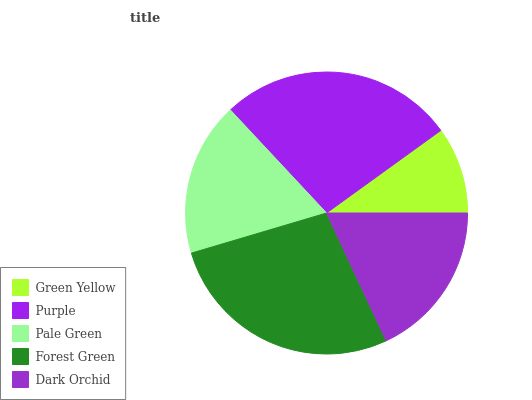Is Green Yellow the minimum?
Answer yes or no. Yes. Is Forest Green the maximum?
Answer yes or no. Yes. Is Purple the minimum?
Answer yes or no. No. Is Purple the maximum?
Answer yes or no. No. Is Purple greater than Green Yellow?
Answer yes or no. Yes. Is Green Yellow less than Purple?
Answer yes or no. Yes. Is Green Yellow greater than Purple?
Answer yes or no. No. Is Purple less than Green Yellow?
Answer yes or no. No. Is Dark Orchid the high median?
Answer yes or no. Yes. Is Dark Orchid the low median?
Answer yes or no. Yes. Is Purple the high median?
Answer yes or no. No. Is Purple the low median?
Answer yes or no. No. 